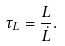<formula> <loc_0><loc_0><loc_500><loc_500>\tau _ { L } = \frac { L } { \dot { L } } .</formula> 